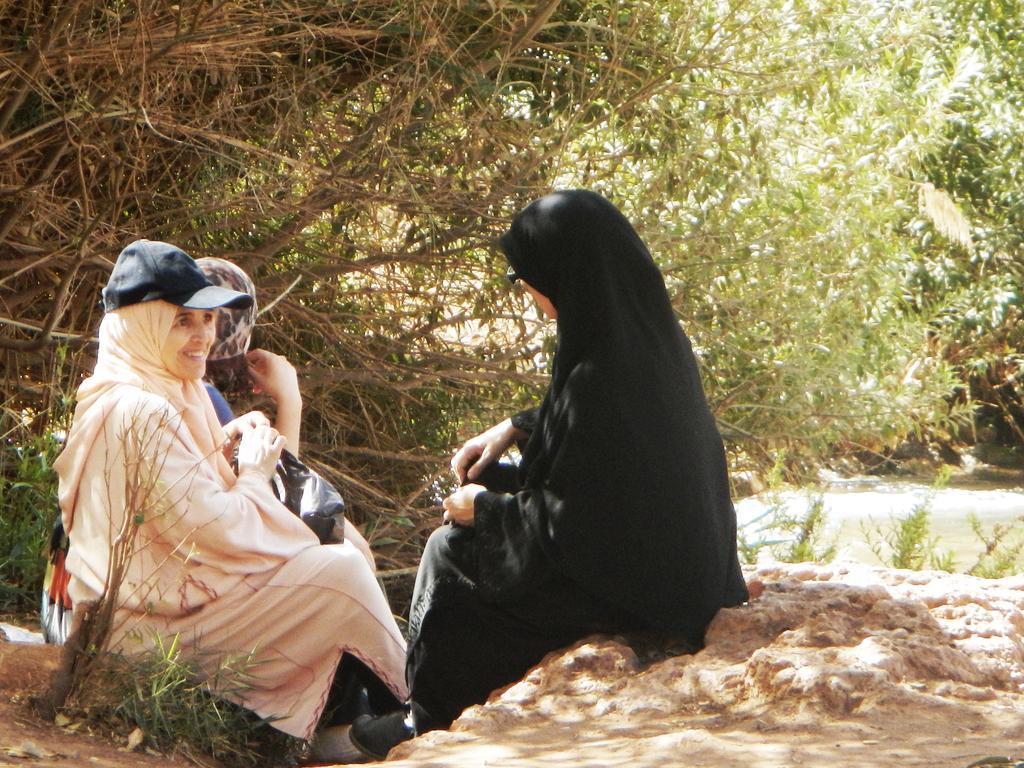In one or two sentences, can you explain what this image depicts? In this image we can see three women are sitting, they are wearing abayas. Background of the image trees are present. 